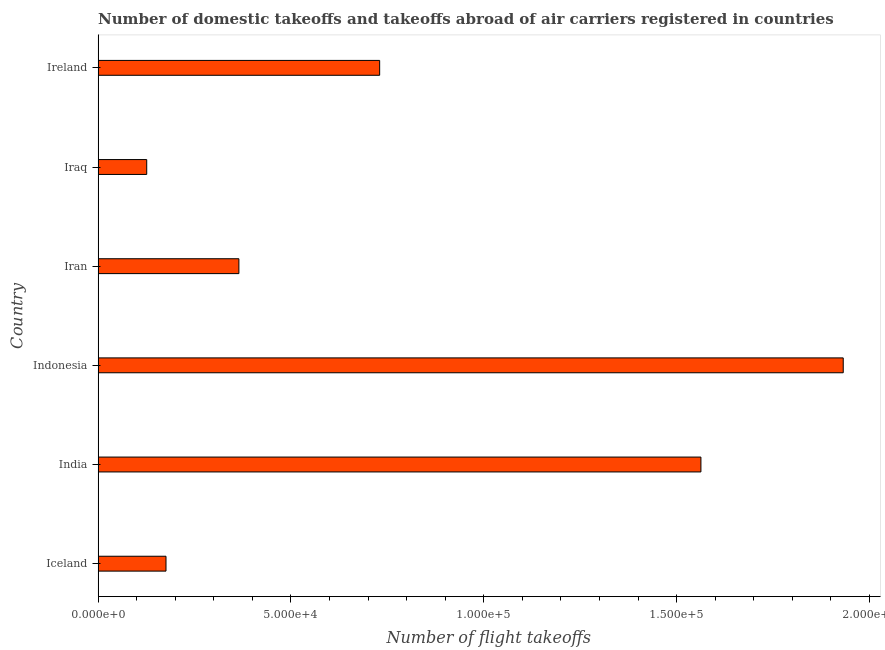What is the title of the graph?
Provide a short and direct response. Number of domestic takeoffs and takeoffs abroad of air carriers registered in countries. What is the label or title of the X-axis?
Keep it short and to the point. Number of flight takeoffs. What is the label or title of the Y-axis?
Offer a terse response. Country. What is the number of flight takeoffs in Iceland?
Keep it short and to the point. 1.76e+04. Across all countries, what is the maximum number of flight takeoffs?
Provide a succinct answer. 1.93e+05. Across all countries, what is the minimum number of flight takeoffs?
Ensure brevity in your answer.  1.26e+04. In which country was the number of flight takeoffs minimum?
Ensure brevity in your answer.  Iraq. What is the sum of the number of flight takeoffs?
Offer a very short reply. 4.89e+05. What is the difference between the number of flight takeoffs in Indonesia and Ireland?
Provide a short and direct response. 1.20e+05. What is the average number of flight takeoffs per country?
Offer a very short reply. 8.15e+04. What is the median number of flight takeoffs?
Ensure brevity in your answer.  5.48e+04. In how many countries, is the number of flight takeoffs greater than 70000 ?
Ensure brevity in your answer.  3. What is the ratio of the number of flight takeoffs in India to that in Iran?
Offer a very short reply. 4.28. Is the difference between the number of flight takeoffs in Iran and Iraq greater than the difference between any two countries?
Give a very brief answer. No. What is the difference between the highest and the second highest number of flight takeoffs?
Ensure brevity in your answer.  3.69e+04. Is the sum of the number of flight takeoffs in India and Iran greater than the maximum number of flight takeoffs across all countries?
Keep it short and to the point. No. What is the difference between the highest and the lowest number of flight takeoffs?
Provide a short and direct response. 1.81e+05. In how many countries, is the number of flight takeoffs greater than the average number of flight takeoffs taken over all countries?
Make the answer very short. 2. Are all the bars in the graph horizontal?
Make the answer very short. Yes. How many countries are there in the graph?
Provide a short and direct response. 6. What is the Number of flight takeoffs in Iceland?
Your answer should be compact. 1.76e+04. What is the Number of flight takeoffs of India?
Provide a short and direct response. 1.56e+05. What is the Number of flight takeoffs of Indonesia?
Your answer should be very brief. 1.93e+05. What is the Number of flight takeoffs of Iran?
Offer a very short reply. 3.65e+04. What is the Number of flight takeoffs of Iraq?
Make the answer very short. 1.26e+04. What is the Number of flight takeoffs of Ireland?
Provide a succinct answer. 7.30e+04. What is the difference between the Number of flight takeoffs in Iceland and India?
Your answer should be very brief. -1.39e+05. What is the difference between the Number of flight takeoffs in Iceland and Indonesia?
Offer a terse response. -1.76e+05. What is the difference between the Number of flight takeoffs in Iceland and Iran?
Give a very brief answer. -1.89e+04. What is the difference between the Number of flight takeoffs in Iceland and Iraq?
Provide a short and direct response. 5000. What is the difference between the Number of flight takeoffs in Iceland and Ireland?
Provide a short and direct response. -5.54e+04. What is the difference between the Number of flight takeoffs in India and Indonesia?
Give a very brief answer. -3.69e+04. What is the difference between the Number of flight takeoffs in India and Iran?
Your response must be concise. 1.20e+05. What is the difference between the Number of flight takeoffs in India and Iraq?
Keep it short and to the point. 1.44e+05. What is the difference between the Number of flight takeoffs in India and Ireland?
Your answer should be very brief. 8.33e+04. What is the difference between the Number of flight takeoffs in Indonesia and Iran?
Keep it short and to the point. 1.57e+05. What is the difference between the Number of flight takeoffs in Indonesia and Iraq?
Your answer should be compact. 1.81e+05. What is the difference between the Number of flight takeoffs in Indonesia and Ireland?
Ensure brevity in your answer.  1.20e+05. What is the difference between the Number of flight takeoffs in Iran and Iraq?
Give a very brief answer. 2.39e+04. What is the difference between the Number of flight takeoffs in Iran and Ireland?
Make the answer very short. -3.65e+04. What is the difference between the Number of flight takeoffs in Iraq and Ireland?
Make the answer very short. -6.04e+04. What is the ratio of the Number of flight takeoffs in Iceland to that in India?
Offer a very short reply. 0.11. What is the ratio of the Number of flight takeoffs in Iceland to that in Indonesia?
Your answer should be very brief. 0.09. What is the ratio of the Number of flight takeoffs in Iceland to that in Iran?
Give a very brief answer. 0.48. What is the ratio of the Number of flight takeoffs in Iceland to that in Iraq?
Make the answer very short. 1.4. What is the ratio of the Number of flight takeoffs in Iceland to that in Ireland?
Provide a short and direct response. 0.24. What is the ratio of the Number of flight takeoffs in India to that in Indonesia?
Your answer should be compact. 0.81. What is the ratio of the Number of flight takeoffs in India to that in Iran?
Your answer should be very brief. 4.28. What is the ratio of the Number of flight takeoffs in India to that in Iraq?
Your answer should be very brief. 12.4. What is the ratio of the Number of flight takeoffs in India to that in Ireland?
Offer a very short reply. 2.14. What is the ratio of the Number of flight takeoffs in Indonesia to that in Iran?
Provide a succinct answer. 5.29. What is the ratio of the Number of flight takeoffs in Indonesia to that in Iraq?
Make the answer very short. 15.33. What is the ratio of the Number of flight takeoffs in Indonesia to that in Ireland?
Offer a very short reply. 2.65. What is the ratio of the Number of flight takeoffs in Iran to that in Iraq?
Your response must be concise. 2.9. What is the ratio of the Number of flight takeoffs in Iran to that in Ireland?
Give a very brief answer. 0.5. What is the ratio of the Number of flight takeoffs in Iraq to that in Ireland?
Ensure brevity in your answer.  0.17. 